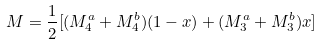<formula> <loc_0><loc_0><loc_500><loc_500>M = \frac { 1 } { 2 } [ ( M _ { 4 } ^ { a } + M _ { 4 } ^ { b } ) ( 1 - x ) + ( M _ { 3 } ^ { a } + M _ { 3 } ^ { b } ) x ]</formula> 